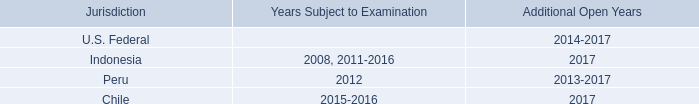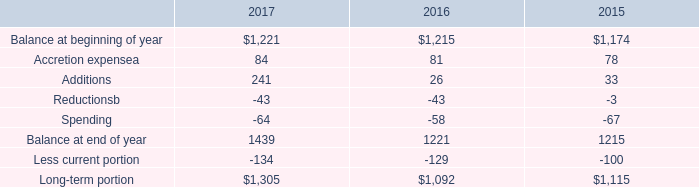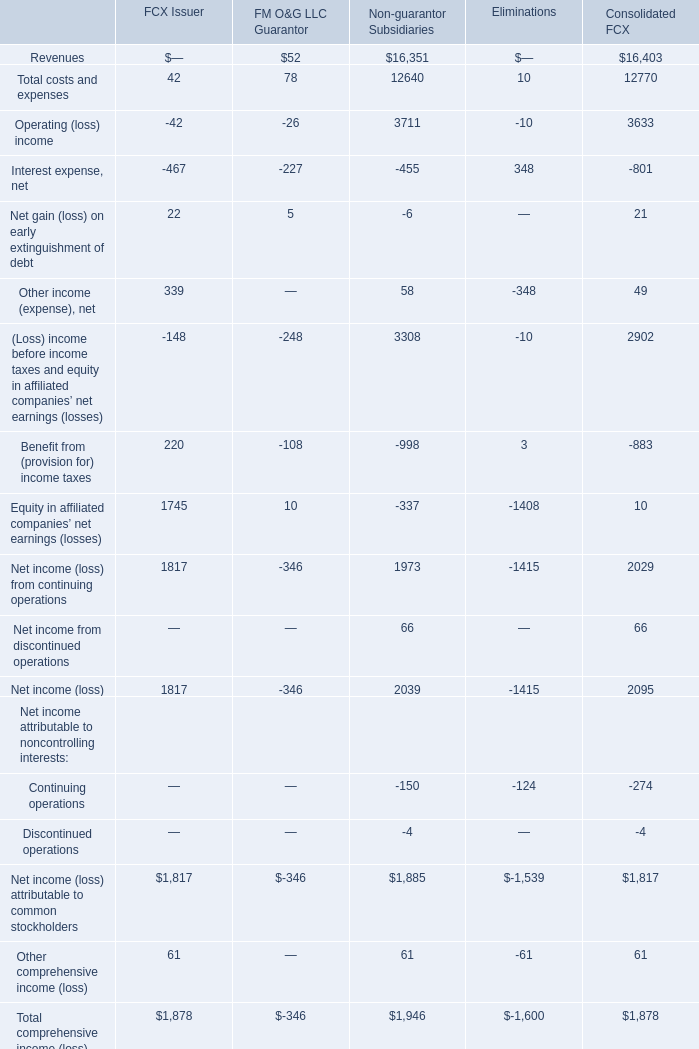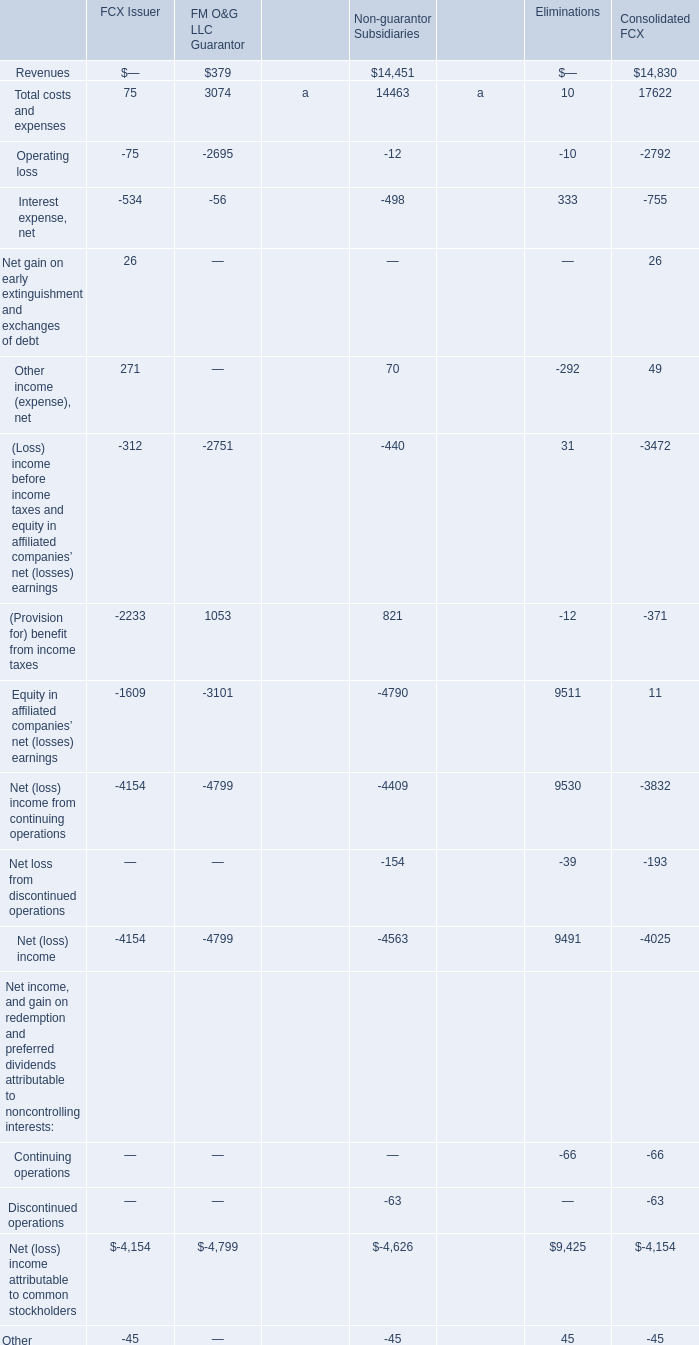What is the sum of Operating (loss) income, Interest expense, net and Net gain (loss) on early extinguishment of debt for FCX Issuer? 
Computations: ((-42 - 467) + 22)
Answer: -487.0. 